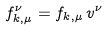Convert formula to latex. <formula><loc_0><loc_0><loc_500><loc_500>f ^ { \nu } _ { k , \mu } = f _ { k , \mu } \, v ^ { \nu }</formula> 